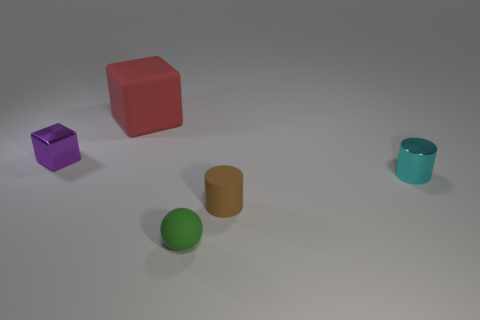Is there anything else that has the same size as the rubber block?
Keep it short and to the point. No. Are there any other things that have the same shape as the green matte object?
Give a very brief answer. No. Is the number of purple objects to the right of the rubber cube greater than the number of small purple shiny things?
Provide a short and direct response. No. Is the number of small matte things that are right of the purple metal block less than the number of spheres?
Keep it short and to the point. No. There is a small object that is both on the right side of the matte cube and behind the small brown rubber object; what is it made of?
Offer a very short reply. Metal. There is a small object on the left side of the big red rubber block; is it the same color as the metallic thing on the right side of the small brown rubber cylinder?
Give a very brief answer. No. What number of brown objects are large things or cylinders?
Ensure brevity in your answer.  1. Are there fewer purple cubes that are on the right side of the tiny green object than tiny cyan objects left of the tiny cyan thing?
Provide a short and direct response. No. Are there any brown matte cubes of the same size as the green rubber object?
Make the answer very short. No. There is a metal object that is on the left side of the red matte cube; is its size the same as the green rubber sphere?
Your answer should be compact. Yes. 